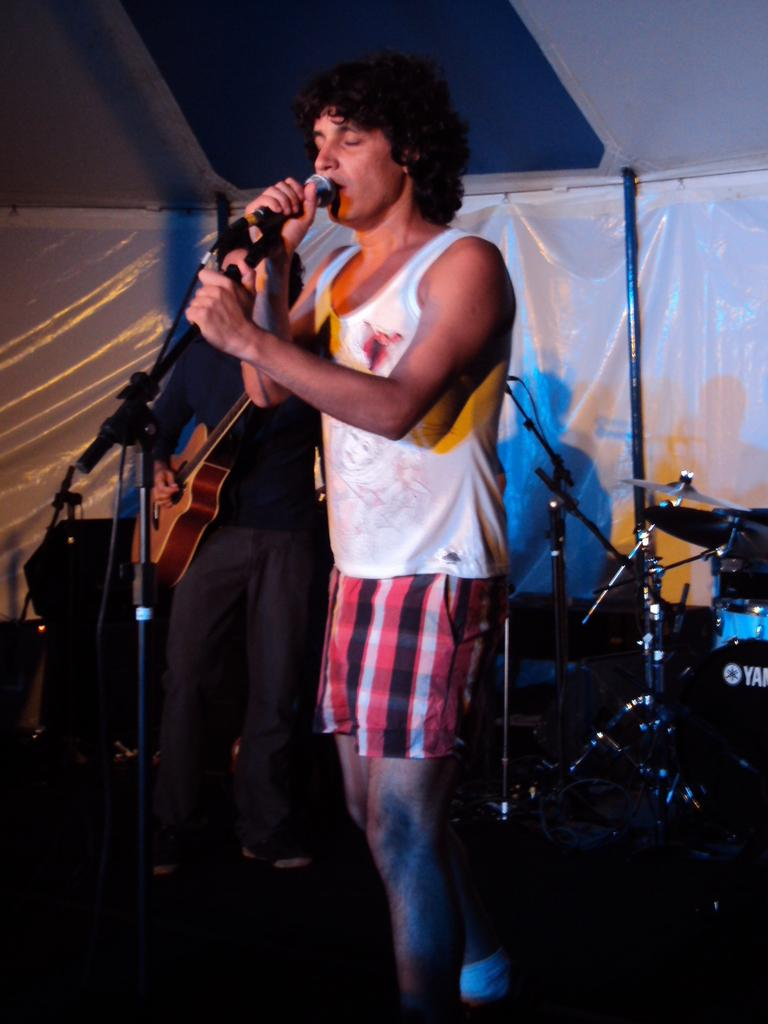What is the man in the image doing? The man is standing in front of a microphone. What is the other man in the image doing? The other man is playing a guitar. What else can be seen in the image besides the two men? There are musical instruments in the image. What is visible in the background of the image? There is a banner in the background. What type of cup is being used to play the guitar in the image? There is no cup being used to play the guitar in the image; it is a guitar being played by a man. 